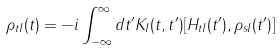<formula> <loc_0><loc_0><loc_500><loc_500>\rho _ { t I } ( t ) = - i \int _ { - \infty } ^ { \infty } d t ^ { \prime } K _ { I } ( t , t ^ { \prime } ) [ H _ { t I } ( t ^ { \prime } ) , \rho _ { s I } ( t ^ { \prime } ) ]</formula> 